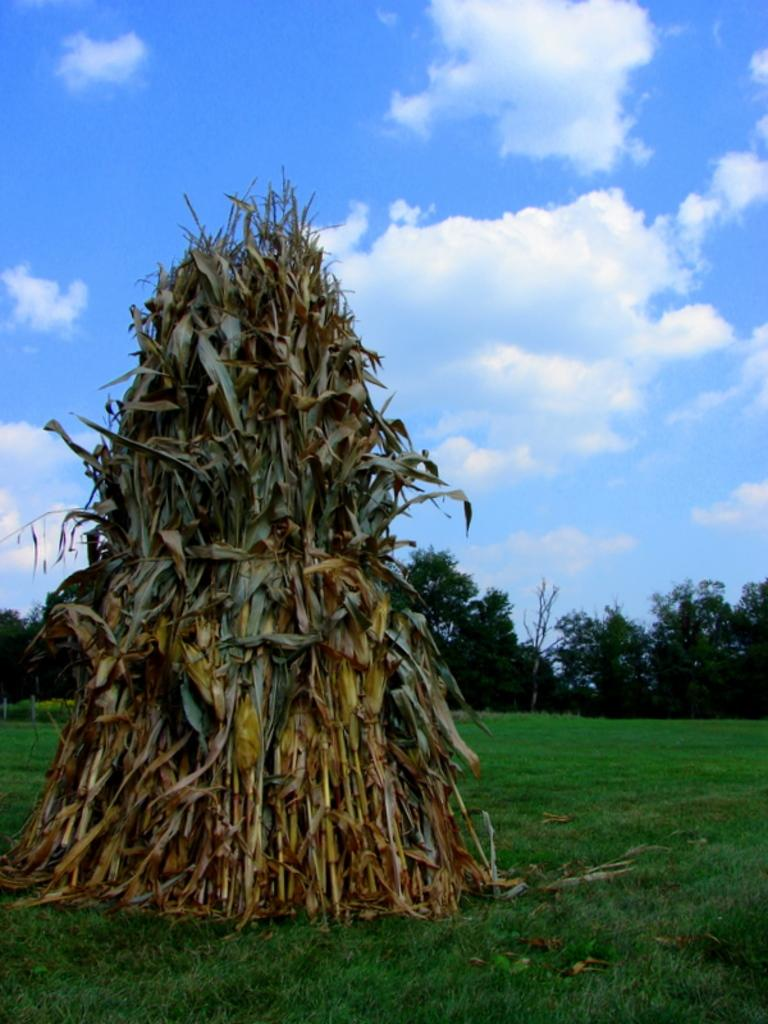What type of vegetation is present on the ground in the front of the image? There is grass on the ground in the front of the image. What can be seen in the center of the image? There are plants in the center of the image. What type of vegetation is visible in the background of the image? There are trees in the background of the image. What is visible in the sky in the background of the image? Clouds are visible in the sky in the background of the image. How many friends are shown taking a bath together in the image? There are no people or baths present in the image; it features vegetation and clouds. 